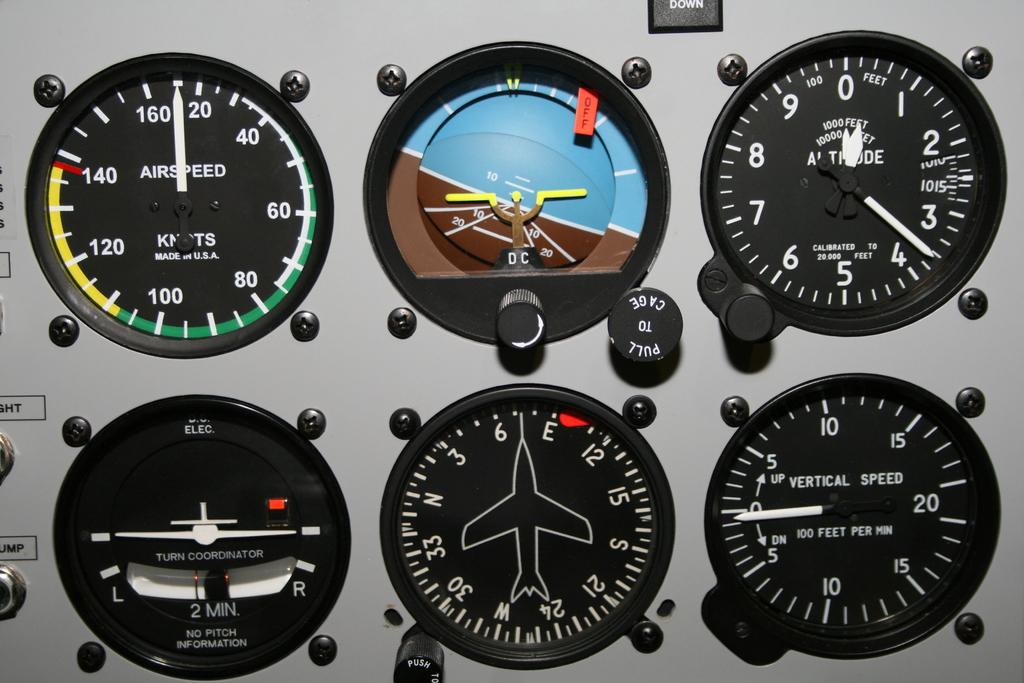Provide a one-sentence caption for the provided image. Among the readouts is one for vertical speed. 